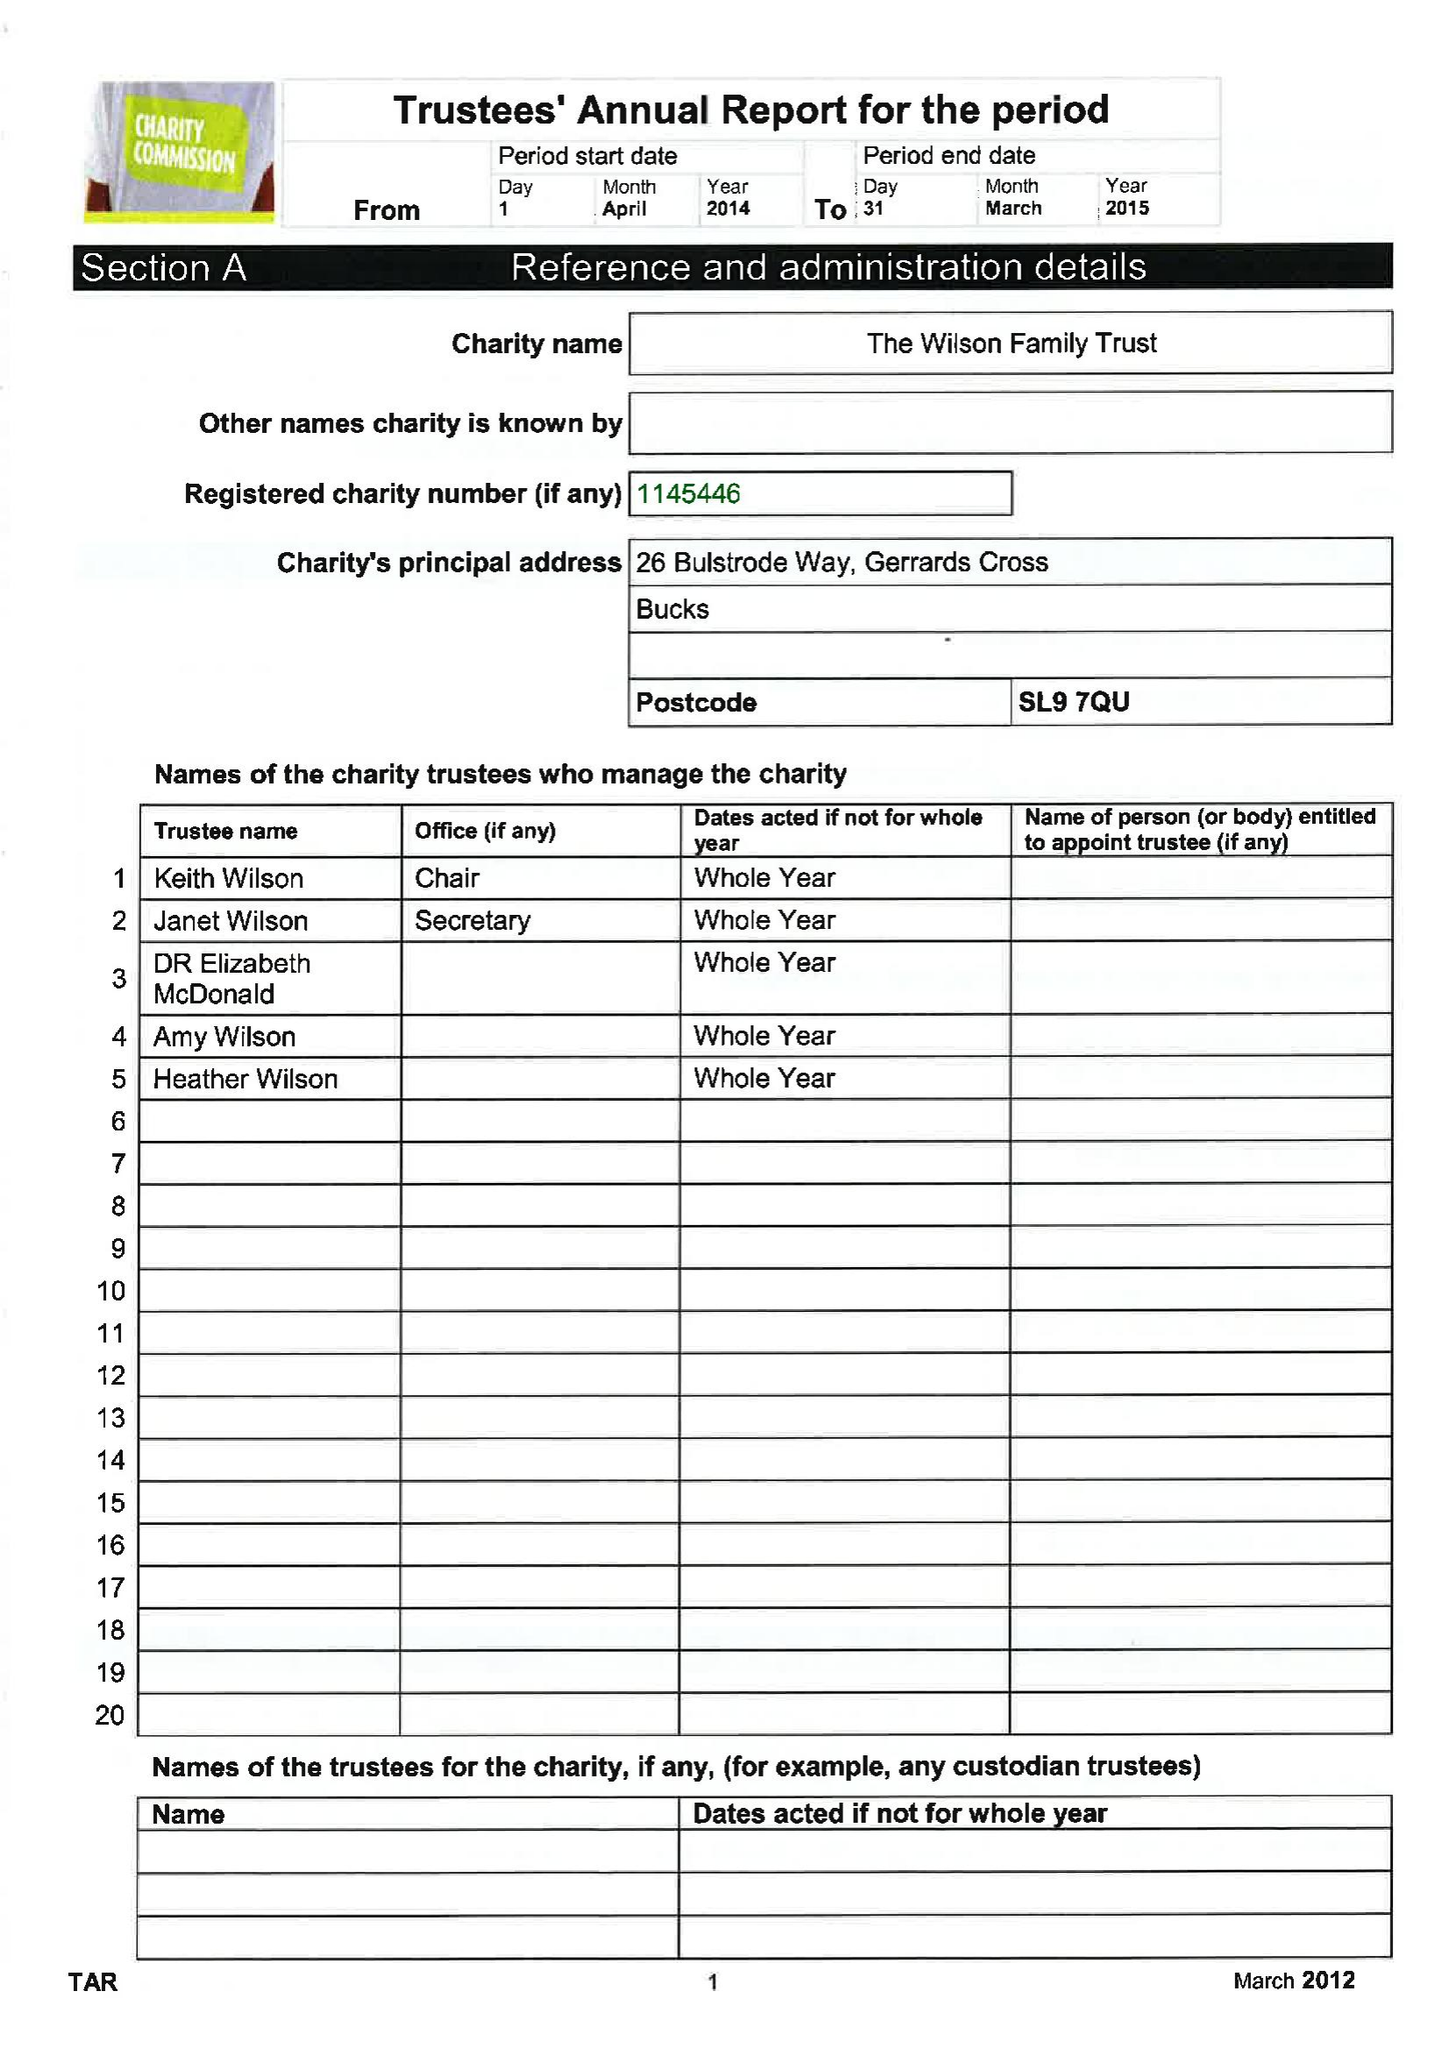What is the value for the address__street_line?
Answer the question using a single word or phrase. 26 BULSTRODE WAY 